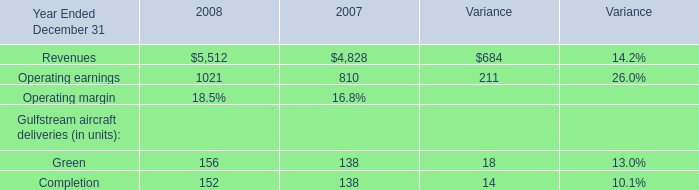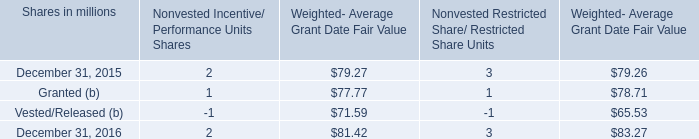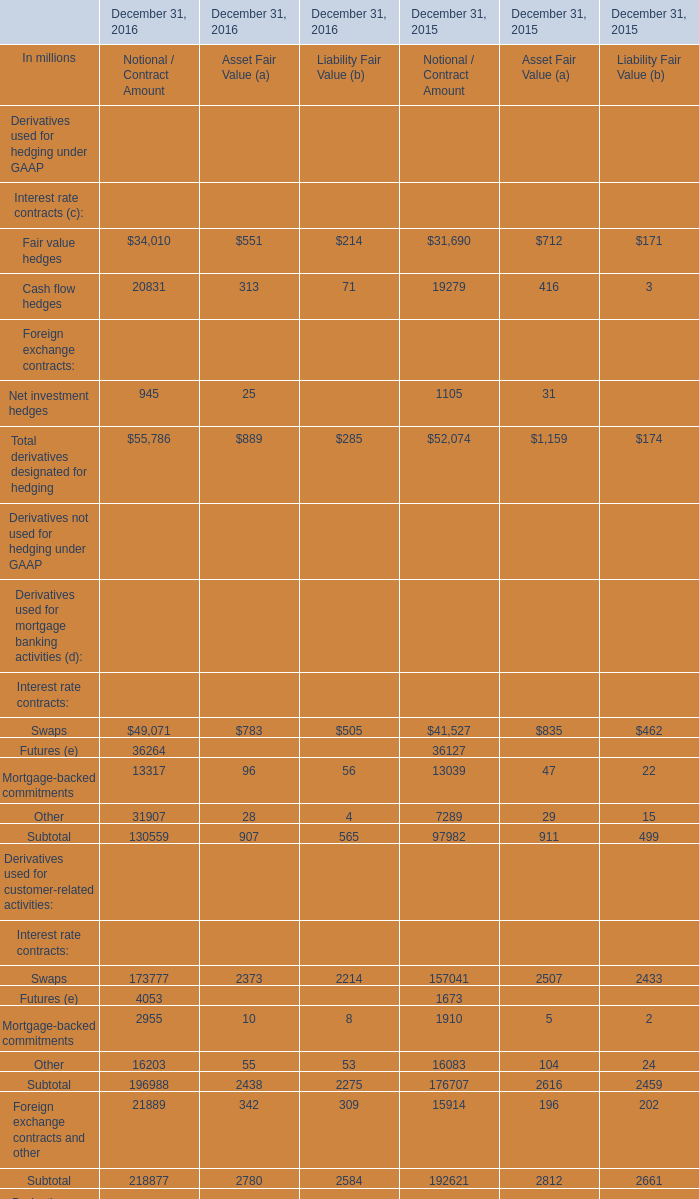How many elements show negative value in 2016 for Notional / Contract Amount? 
Answer: 0. 